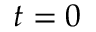<formula> <loc_0><loc_0><loc_500><loc_500>t = 0</formula> 